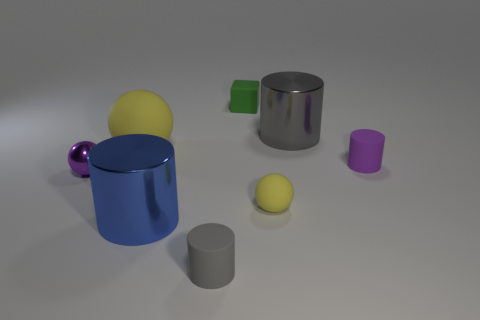Subtract 1 cylinders. How many cylinders are left? 3 Add 2 small purple things. How many objects exist? 10 Subtract all balls. How many objects are left? 5 Subtract 1 blue cylinders. How many objects are left? 7 Subtract all large red shiny objects. Subtract all green matte cubes. How many objects are left? 7 Add 4 tiny purple matte objects. How many tiny purple matte objects are left? 5 Add 6 tiny green rubber cubes. How many tiny green rubber cubes exist? 7 